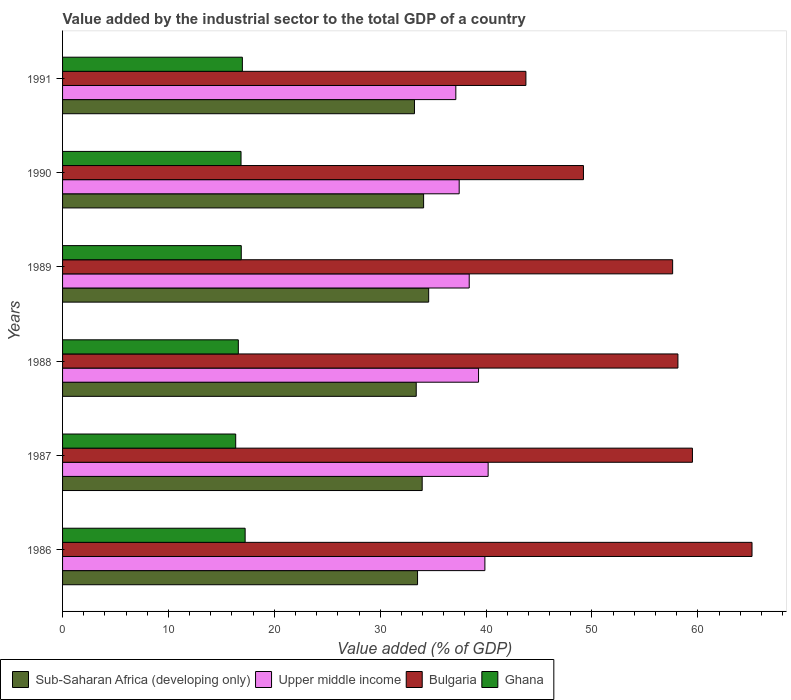Are the number of bars per tick equal to the number of legend labels?
Ensure brevity in your answer.  Yes. Are the number of bars on each tick of the Y-axis equal?
Provide a succinct answer. Yes. How many bars are there on the 3rd tick from the top?
Offer a terse response. 4. How many bars are there on the 5th tick from the bottom?
Offer a very short reply. 4. In how many cases, is the number of bars for a given year not equal to the number of legend labels?
Your response must be concise. 0. What is the value added by the industrial sector to the total GDP in Ghana in 1988?
Give a very brief answer. 16.6. Across all years, what is the maximum value added by the industrial sector to the total GDP in Sub-Saharan Africa (developing only)?
Give a very brief answer. 34.58. Across all years, what is the minimum value added by the industrial sector to the total GDP in Bulgaria?
Offer a terse response. 43.76. In which year was the value added by the industrial sector to the total GDP in Sub-Saharan Africa (developing only) minimum?
Keep it short and to the point. 1991. What is the total value added by the industrial sector to the total GDP in Sub-Saharan Africa (developing only) in the graph?
Offer a terse response. 202.81. What is the difference between the value added by the industrial sector to the total GDP in Ghana in 1986 and that in 1990?
Ensure brevity in your answer.  0.39. What is the difference between the value added by the industrial sector to the total GDP in Upper middle income in 1987 and the value added by the industrial sector to the total GDP in Ghana in 1991?
Your answer should be very brief. 23.21. What is the average value added by the industrial sector to the total GDP in Ghana per year?
Make the answer very short. 16.82. In the year 1990, what is the difference between the value added by the industrial sector to the total GDP in Sub-Saharan Africa (developing only) and value added by the industrial sector to the total GDP in Upper middle income?
Keep it short and to the point. -3.36. What is the ratio of the value added by the industrial sector to the total GDP in Upper middle income in 1990 to that in 1991?
Give a very brief answer. 1.01. What is the difference between the highest and the second highest value added by the industrial sector to the total GDP in Ghana?
Your answer should be very brief. 0.26. What is the difference between the highest and the lowest value added by the industrial sector to the total GDP in Bulgaria?
Provide a short and direct response. 21.36. In how many years, is the value added by the industrial sector to the total GDP in Sub-Saharan Africa (developing only) greater than the average value added by the industrial sector to the total GDP in Sub-Saharan Africa (developing only) taken over all years?
Provide a succinct answer. 3. Is the sum of the value added by the industrial sector to the total GDP in Upper middle income in 1990 and 1991 greater than the maximum value added by the industrial sector to the total GDP in Bulgaria across all years?
Ensure brevity in your answer.  Yes. Is it the case that in every year, the sum of the value added by the industrial sector to the total GDP in Ghana and value added by the industrial sector to the total GDP in Bulgaria is greater than the sum of value added by the industrial sector to the total GDP in Upper middle income and value added by the industrial sector to the total GDP in Sub-Saharan Africa (developing only)?
Offer a very short reply. No. What does the 2nd bar from the top in 1989 represents?
Your answer should be very brief. Bulgaria. What does the 1st bar from the bottom in 1986 represents?
Your response must be concise. Sub-Saharan Africa (developing only). Is it the case that in every year, the sum of the value added by the industrial sector to the total GDP in Sub-Saharan Africa (developing only) and value added by the industrial sector to the total GDP in Upper middle income is greater than the value added by the industrial sector to the total GDP in Bulgaria?
Ensure brevity in your answer.  Yes. What is the difference between two consecutive major ticks on the X-axis?
Keep it short and to the point. 10. Does the graph contain grids?
Ensure brevity in your answer.  No. Where does the legend appear in the graph?
Provide a succinct answer. Bottom left. How are the legend labels stacked?
Your answer should be very brief. Horizontal. What is the title of the graph?
Provide a succinct answer. Value added by the industrial sector to the total GDP of a country. What is the label or title of the X-axis?
Provide a succinct answer. Value added (% of GDP). What is the Value added (% of GDP) of Sub-Saharan Africa (developing only) in 1986?
Provide a short and direct response. 33.53. What is the Value added (% of GDP) in Upper middle income in 1986?
Give a very brief answer. 39.89. What is the Value added (% of GDP) in Bulgaria in 1986?
Keep it short and to the point. 65.12. What is the Value added (% of GDP) in Ghana in 1986?
Provide a short and direct response. 17.24. What is the Value added (% of GDP) in Sub-Saharan Africa (developing only) in 1987?
Make the answer very short. 33.97. What is the Value added (% of GDP) in Upper middle income in 1987?
Make the answer very short. 40.19. What is the Value added (% of GDP) in Bulgaria in 1987?
Your response must be concise. 59.49. What is the Value added (% of GDP) of Ghana in 1987?
Offer a very short reply. 16.35. What is the Value added (% of GDP) of Sub-Saharan Africa (developing only) in 1988?
Keep it short and to the point. 33.4. What is the Value added (% of GDP) in Upper middle income in 1988?
Provide a succinct answer. 39.29. What is the Value added (% of GDP) in Bulgaria in 1988?
Provide a succinct answer. 58.12. What is the Value added (% of GDP) in Ghana in 1988?
Ensure brevity in your answer.  16.6. What is the Value added (% of GDP) in Sub-Saharan Africa (developing only) in 1989?
Provide a succinct answer. 34.58. What is the Value added (% of GDP) in Upper middle income in 1989?
Keep it short and to the point. 38.41. What is the Value added (% of GDP) in Bulgaria in 1989?
Provide a short and direct response. 57.62. What is the Value added (% of GDP) in Ghana in 1989?
Your response must be concise. 16.88. What is the Value added (% of GDP) of Sub-Saharan Africa (developing only) in 1990?
Offer a terse response. 34.1. What is the Value added (% of GDP) in Upper middle income in 1990?
Make the answer very short. 37.46. What is the Value added (% of GDP) of Bulgaria in 1990?
Your answer should be very brief. 49.2. What is the Value added (% of GDP) of Ghana in 1990?
Give a very brief answer. 16.86. What is the Value added (% of GDP) of Sub-Saharan Africa (developing only) in 1991?
Your answer should be compact. 33.24. What is the Value added (% of GDP) in Upper middle income in 1991?
Give a very brief answer. 37.14. What is the Value added (% of GDP) in Bulgaria in 1991?
Ensure brevity in your answer.  43.76. What is the Value added (% of GDP) of Ghana in 1991?
Offer a terse response. 16.98. Across all years, what is the maximum Value added (% of GDP) of Sub-Saharan Africa (developing only)?
Your answer should be compact. 34.58. Across all years, what is the maximum Value added (% of GDP) of Upper middle income?
Give a very brief answer. 40.19. Across all years, what is the maximum Value added (% of GDP) in Bulgaria?
Your answer should be very brief. 65.12. Across all years, what is the maximum Value added (% of GDP) of Ghana?
Keep it short and to the point. 17.24. Across all years, what is the minimum Value added (% of GDP) in Sub-Saharan Africa (developing only)?
Keep it short and to the point. 33.24. Across all years, what is the minimum Value added (% of GDP) in Upper middle income?
Make the answer very short. 37.14. Across all years, what is the minimum Value added (% of GDP) of Bulgaria?
Your response must be concise. 43.76. Across all years, what is the minimum Value added (% of GDP) in Ghana?
Your answer should be very brief. 16.35. What is the total Value added (% of GDP) of Sub-Saharan Africa (developing only) in the graph?
Your response must be concise. 202.81. What is the total Value added (% of GDP) in Upper middle income in the graph?
Provide a succinct answer. 232.38. What is the total Value added (% of GDP) in Bulgaria in the graph?
Ensure brevity in your answer.  333.3. What is the total Value added (% of GDP) of Ghana in the graph?
Provide a succinct answer. 100.91. What is the difference between the Value added (% of GDP) of Sub-Saharan Africa (developing only) in 1986 and that in 1987?
Ensure brevity in your answer.  -0.44. What is the difference between the Value added (% of GDP) of Upper middle income in 1986 and that in 1987?
Keep it short and to the point. -0.31. What is the difference between the Value added (% of GDP) of Bulgaria in 1986 and that in 1987?
Your answer should be compact. 5.63. What is the difference between the Value added (% of GDP) in Ghana in 1986 and that in 1987?
Your answer should be compact. 0.89. What is the difference between the Value added (% of GDP) in Sub-Saharan Africa (developing only) in 1986 and that in 1988?
Keep it short and to the point. 0.12. What is the difference between the Value added (% of GDP) of Upper middle income in 1986 and that in 1988?
Offer a very short reply. 0.6. What is the difference between the Value added (% of GDP) in Bulgaria in 1986 and that in 1988?
Your answer should be very brief. 7. What is the difference between the Value added (% of GDP) of Ghana in 1986 and that in 1988?
Offer a terse response. 0.64. What is the difference between the Value added (% of GDP) of Sub-Saharan Africa (developing only) in 1986 and that in 1989?
Make the answer very short. -1.05. What is the difference between the Value added (% of GDP) in Upper middle income in 1986 and that in 1989?
Make the answer very short. 1.48. What is the difference between the Value added (% of GDP) in Bulgaria in 1986 and that in 1989?
Your response must be concise. 7.5. What is the difference between the Value added (% of GDP) in Ghana in 1986 and that in 1989?
Provide a succinct answer. 0.37. What is the difference between the Value added (% of GDP) in Sub-Saharan Africa (developing only) in 1986 and that in 1990?
Offer a very short reply. -0.57. What is the difference between the Value added (% of GDP) of Upper middle income in 1986 and that in 1990?
Keep it short and to the point. 2.43. What is the difference between the Value added (% of GDP) of Bulgaria in 1986 and that in 1990?
Provide a short and direct response. 15.92. What is the difference between the Value added (% of GDP) of Ghana in 1986 and that in 1990?
Offer a terse response. 0.39. What is the difference between the Value added (% of GDP) in Sub-Saharan Africa (developing only) in 1986 and that in 1991?
Ensure brevity in your answer.  0.29. What is the difference between the Value added (% of GDP) of Upper middle income in 1986 and that in 1991?
Keep it short and to the point. 2.75. What is the difference between the Value added (% of GDP) of Bulgaria in 1986 and that in 1991?
Provide a succinct answer. 21.36. What is the difference between the Value added (% of GDP) in Ghana in 1986 and that in 1991?
Give a very brief answer. 0.26. What is the difference between the Value added (% of GDP) in Sub-Saharan Africa (developing only) in 1987 and that in 1988?
Provide a short and direct response. 0.56. What is the difference between the Value added (% of GDP) of Upper middle income in 1987 and that in 1988?
Offer a terse response. 0.9. What is the difference between the Value added (% of GDP) of Bulgaria in 1987 and that in 1988?
Keep it short and to the point. 1.37. What is the difference between the Value added (% of GDP) of Ghana in 1987 and that in 1988?
Your response must be concise. -0.25. What is the difference between the Value added (% of GDP) of Sub-Saharan Africa (developing only) in 1987 and that in 1989?
Your answer should be compact. -0.61. What is the difference between the Value added (% of GDP) in Upper middle income in 1987 and that in 1989?
Your answer should be compact. 1.79. What is the difference between the Value added (% of GDP) in Bulgaria in 1987 and that in 1989?
Offer a terse response. 1.87. What is the difference between the Value added (% of GDP) of Ghana in 1987 and that in 1989?
Provide a short and direct response. -0.53. What is the difference between the Value added (% of GDP) of Sub-Saharan Africa (developing only) in 1987 and that in 1990?
Your response must be concise. -0.13. What is the difference between the Value added (% of GDP) of Upper middle income in 1987 and that in 1990?
Keep it short and to the point. 2.73. What is the difference between the Value added (% of GDP) in Bulgaria in 1987 and that in 1990?
Your answer should be compact. 10.29. What is the difference between the Value added (% of GDP) in Ghana in 1987 and that in 1990?
Provide a succinct answer. -0.5. What is the difference between the Value added (% of GDP) in Sub-Saharan Africa (developing only) in 1987 and that in 1991?
Your answer should be compact. 0.73. What is the difference between the Value added (% of GDP) in Upper middle income in 1987 and that in 1991?
Offer a terse response. 3.05. What is the difference between the Value added (% of GDP) of Bulgaria in 1987 and that in 1991?
Make the answer very short. 15.73. What is the difference between the Value added (% of GDP) in Ghana in 1987 and that in 1991?
Provide a succinct answer. -0.63. What is the difference between the Value added (% of GDP) of Sub-Saharan Africa (developing only) in 1988 and that in 1989?
Make the answer very short. -1.17. What is the difference between the Value added (% of GDP) in Upper middle income in 1988 and that in 1989?
Give a very brief answer. 0.88. What is the difference between the Value added (% of GDP) of Bulgaria in 1988 and that in 1989?
Offer a terse response. 0.5. What is the difference between the Value added (% of GDP) in Ghana in 1988 and that in 1989?
Your response must be concise. -0.28. What is the difference between the Value added (% of GDP) in Sub-Saharan Africa (developing only) in 1988 and that in 1990?
Your answer should be very brief. -0.7. What is the difference between the Value added (% of GDP) in Upper middle income in 1988 and that in 1990?
Your response must be concise. 1.83. What is the difference between the Value added (% of GDP) in Bulgaria in 1988 and that in 1990?
Give a very brief answer. 8.92. What is the difference between the Value added (% of GDP) of Ghana in 1988 and that in 1990?
Make the answer very short. -0.25. What is the difference between the Value added (% of GDP) of Sub-Saharan Africa (developing only) in 1988 and that in 1991?
Your response must be concise. 0.17. What is the difference between the Value added (% of GDP) of Upper middle income in 1988 and that in 1991?
Provide a short and direct response. 2.15. What is the difference between the Value added (% of GDP) of Bulgaria in 1988 and that in 1991?
Your response must be concise. 14.36. What is the difference between the Value added (% of GDP) of Ghana in 1988 and that in 1991?
Your response must be concise. -0.38. What is the difference between the Value added (% of GDP) of Sub-Saharan Africa (developing only) in 1989 and that in 1990?
Your answer should be very brief. 0.48. What is the difference between the Value added (% of GDP) of Upper middle income in 1989 and that in 1990?
Ensure brevity in your answer.  0.95. What is the difference between the Value added (% of GDP) of Bulgaria in 1989 and that in 1990?
Ensure brevity in your answer.  8.42. What is the difference between the Value added (% of GDP) in Ghana in 1989 and that in 1990?
Your answer should be very brief. 0.02. What is the difference between the Value added (% of GDP) of Sub-Saharan Africa (developing only) in 1989 and that in 1991?
Give a very brief answer. 1.34. What is the difference between the Value added (% of GDP) in Upper middle income in 1989 and that in 1991?
Keep it short and to the point. 1.26. What is the difference between the Value added (% of GDP) of Bulgaria in 1989 and that in 1991?
Offer a terse response. 13.86. What is the difference between the Value added (% of GDP) of Ghana in 1989 and that in 1991?
Your answer should be compact. -0.1. What is the difference between the Value added (% of GDP) of Sub-Saharan Africa (developing only) in 1990 and that in 1991?
Offer a terse response. 0.86. What is the difference between the Value added (% of GDP) in Upper middle income in 1990 and that in 1991?
Provide a succinct answer. 0.32. What is the difference between the Value added (% of GDP) in Bulgaria in 1990 and that in 1991?
Give a very brief answer. 5.44. What is the difference between the Value added (% of GDP) of Ghana in 1990 and that in 1991?
Give a very brief answer. -0.13. What is the difference between the Value added (% of GDP) of Sub-Saharan Africa (developing only) in 1986 and the Value added (% of GDP) of Upper middle income in 1987?
Make the answer very short. -6.67. What is the difference between the Value added (% of GDP) in Sub-Saharan Africa (developing only) in 1986 and the Value added (% of GDP) in Bulgaria in 1987?
Ensure brevity in your answer.  -25.96. What is the difference between the Value added (% of GDP) of Sub-Saharan Africa (developing only) in 1986 and the Value added (% of GDP) of Ghana in 1987?
Keep it short and to the point. 17.17. What is the difference between the Value added (% of GDP) in Upper middle income in 1986 and the Value added (% of GDP) in Bulgaria in 1987?
Your response must be concise. -19.6. What is the difference between the Value added (% of GDP) of Upper middle income in 1986 and the Value added (% of GDP) of Ghana in 1987?
Make the answer very short. 23.54. What is the difference between the Value added (% of GDP) of Bulgaria in 1986 and the Value added (% of GDP) of Ghana in 1987?
Offer a very short reply. 48.76. What is the difference between the Value added (% of GDP) of Sub-Saharan Africa (developing only) in 1986 and the Value added (% of GDP) of Upper middle income in 1988?
Keep it short and to the point. -5.76. What is the difference between the Value added (% of GDP) of Sub-Saharan Africa (developing only) in 1986 and the Value added (% of GDP) of Bulgaria in 1988?
Your answer should be very brief. -24.59. What is the difference between the Value added (% of GDP) in Sub-Saharan Africa (developing only) in 1986 and the Value added (% of GDP) in Ghana in 1988?
Your response must be concise. 16.93. What is the difference between the Value added (% of GDP) in Upper middle income in 1986 and the Value added (% of GDP) in Bulgaria in 1988?
Offer a very short reply. -18.23. What is the difference between the Value added (% of GDP) of Upper middle income in 1986 and the Value added (% of GDP) of Ghana in 1988?
Provide a short and direct response. 23.29. What is the difference between the Value added (% of GDP) of Bulgaria in 1986 and the Value added (% of GDP) of Ghana in 1988?
Your answer should be very brief. 48.52. What is the difference between the Value added (% of GDP) in Sub-Saharan Africa (developing only) in 1986 and the Value added (% of GDP) in Upper middle income in 1989?
Give a very brief answer. -4.88. What is the difference between the Value added (% of GDP) in Sub-Saharan Africa (developing only) in 1986 and the Value added (% of GDP) in Bulgaria in 1989?
Provide a succinct answer. -24.09. What is the difference between the Value added (% of GDP) in Sub-Saharan Africa (developing only) in 1986 and the Value added (% of GDP) in Ghana in 1989?
Your answer should be very brief. 16.65. What is the difference between the Value added (% of GDP) in Upper middle income in 1986 and the Value added (% of GDP) in Bulgaria in 1989?
Offer a terse response. -17.73. What is the difference between the Value added (% of GDP) of Upper middle income in 1986 and the Value added (% of GDP) of Ghana in 1989?
Offer a very short reply. 23.01. What is the difference between the Value added (% of GDP) in Bulgaria in 1986 and the Value added (% of GDP) in Ghana in 1989?
Provide a succinct answer. 48.24. What is the difference between the Value added (% of GDP) of Sub-Saharan Africa (developing only) in 1986 and the Value added (% of GDP) of Upper middle income in 1990?
Your response must be concise. -3.93. What is the difference between the Value added (% of GDP) in Sub-Saharan Africa (developing only) in 1986 and the Value added (% of GDP) in Bulgaria in 1990?
Ensure brevity in your answer.  -15.67. What is the difference between the Value added (% of GDP) in Sub-Saharan Africa (developing only) in 1986 and the Value added (% of GDP) in Ghana in 1990?
Your answer should be compact. 16.67. What is the difference between the Value added (% of GDP) in Upper middle income in 1986 and the Value added (% of GDP) in Bulgaria in 1990?
Keep it short and to the point. -9.31. What is the difference between the Value added (% of GDP) in Upper middle income in 1986 and the Value added (% of GDP) in Ghana in 1990?
Offer a terse response. 23.03. What is the difference between the Value added (% of GDP) of Bulgaria in 1986 and the Value added (% of GDP) of Ghana in 1990?
Your response must be concise. 48.26. What is the difference between the Value added (% of GDP) in Sub-Saharan Africa (developing only) in 1986 and the Value added (% of GDP) in Upper middle income in 1991?
Your answer should be very brief. -3.62. What is the difference between the Value added (% of GDP) of Sub-Saharan Africa (developing only) in 1986 and the Value added (% of GDP) of Bulgaria in 1991?
Your answer should be very brief. -10.23. What is the difference between the Value added (% of GDP) in Sub-Saharan Africa (developing only) in 1986 and the Value added (% of GDP) in Ghana in 1991?
Make the answer very short. 16.54. What is the difference between the Value added (% of GDP) in Upper middle income in 1986 and the Value added (% of GDP) in Bulgaria in 1991?
Provide a short and direct response. -3.87. What is the difference between the Value added (% of GDP) of Upper middle income in 1986 and the Value added (% of GDP) of Ghana in 1991?
Give a very brief answer. 22.9. What is the difference between the Value added (% of GDP) in Bulgaria in 1986 and the Value added (% of GDP) in Ghana in 1991?
Keep it short and to the point. 48.13. What is the difference between the Value added (% of GDP) of Sub-Saharan Africa (developing only) in 1987 and the Value added (% of GDP) of Upper middle income in 1988?
Your response must be concise. -5.32. What is the difference between the Value added (% of GDP) of Sub-Saharan Africa (developing only) in 1987 and the Value added (% of GDP) of Bulgaria in 1988?
Your answer should be compact. -24.15. What is the difference between the Value added (% of GDP) of Sub-Saharan Africa (developing only) in 1987 and the Value added (% of GDP) of Ghana in 1988?
Ensure brevity in your answer.  17.37. What is the difference between the Value added (% of GDP) in Upper middle income in 1987 and the Value added (% of GDP) in Bulgaria in 1988?
Provide a short and direct response. -17.92. What is the difference between the Value added (% of GDP) of Upper middle income in 1987 and the Value added (% of GDP) of Ghana in 1988?
Make the answer very short. 23.59. What is the difference between the Value added (% of GDP) in Bulgaria in 1987 and the Value added (% of GDP) in Ghana in 1988?
Provide a succinct answer. 42.89. What is the difference between the Value added (% of GDP) of Sub-Saharan Africa (developing only) in 1987 and the Value added (% of GDP) of Upper middle income in 1989?
Your answer should be compact. -4.44. What is the difference between the Value added (% of GDP) of Sub-Saharan Africa (developing only) in 1987 and the Value added (% of GDP) of Bulgaria in 1989?
Make the answer very short. -23.65. What is the difference between the Value added (% of GDP) in Sub-Saharan Africa (developing only) in 1987 and the Value added (% of GDP) in Ghana in 1989?
Your answer should be very brief. 17.09. What is the difference between the Value added (% of GDP) of Upper middle income in 1987 and the Value added (% of GDP) of Bulgaria in 1989?
Make the answer very short. -17.43. What is the difference between the Value added (% of GDP) in Upper middle income in 1987 and the Value added (% of GDP) in Ghana in 1989?
Provide a succinct answer. 23.32. What is the difference between the Value added (% of GDP) of Bulgaria in 1987 and the Value added (% of GDP) of Ghana in 1989?
Provide a short and direct response. 42.61. What is the difference between the Value added (% of GDP) of Sub-Saharan Africa (developing only) in 1987 and the Value added (% of GDP) of Upper middle income in 1990?
Keep it short and to the point. -3.49. What is the difference between the Value added (% of GDP) of Sub-Saharan Africa (developing only) in 1987 and the Value added (% of GDP) of Bulgaria in 1990?
Keep it short and to the point. -15.23. What is the difference between the Value added (% of GDP) of Sub-Saharan Africa (developing only) in 1987 and the Value added (% of GDP) of Ghana in 1990?
Keep it short and to the point. 17.11. What is the difference between the Value added (% of GDP) of Upper middle income in 1987 and the Value added (% of GDP) of Bulgaria in 1990?
Provide a short and direct response. -9. What is the difference between the Value added (% of GDP) in Upper middle income in 1987 and the Value added (% of GDP) in Ghana in 1990?
Provide a succinct answer. 23.34. What is the difference between the Value added (% of GDP) in Bulgaria in 1987 and the Value added (% of GDP) in Ghana in 1990?
Make the answer very short. 42.64. What is the difference between the Value added (% of GDP) in Sub-Saharan Africa (developing only) in 1987 and the Value added (% of GDP) in Upper middle income in 1991?
Your response must be concise. -3.18. What is the difference between the Value added (% of GDP) in Sub-Saharan Africa (developing only) in 1987 and the Value added (% of GDP) in Bulgaria in 1991?
Your response must be concise. -9.8. What is the difference between the Value added (% of GDP) in Sub-Saharan Africa (developing only) in 1987 and the Value added (% of GDP) in Ghana in 1991?
Provide a succinct answer. 16.98. What is the difference between the Value added (% of GDP) of Upper middle income in 1987 and the Value added (% of GDP) of Bulgaria in 1991?
Offer a terse response. -3.57. What is the difference between the Value added (% of GDP) of Upper middle income in 1987 and the Value added (% of GDP) of Ghana in 1991?
Offer a terse response. 23.21. What is the difference between the Value added (% of GDP) of Bulgaria in 1987 and the Value added (% of GDP) of Ghana in 1991?
Give a very brief answer. 42.51. What is the difference between the Value added (% of GDP) of Sub-Saharan Africa (developing only) in 1988 and the Value added (% of GDP) of Upper middle income in 1989?
Give a very brief answer. -5. What is the difference between the Value added (% of GDP) in Sub-Saharan Africa (developing only) in 1988 and the Value added (% of GDP) in Bulgaria in 1989?
Provide a short and direct response. -24.22. What is the difference between the Value added (% of GDP) of Sub-Saharan Africa (developing only) in 1988 and the Value added (% of GDP) of Ghana in 1989?
Provide a short and direct response. 16.53. What is the difference between the Value added (% of GDP) in Upper middle income in 1988 and the Value added (% of GDP) in Bulgaria in 1989?
Ensure brevity in your answer.  -18.33. What is the difference between the Value added (% of GDP) in Upper middle income in 1988 and the Value added (% of GDP) in Ghana in 1989?
Keep it short and to the point. 22.41. What is the difference between the Value added (% of GDP) of Bulgaria in 1988 and the Value added (% of GDP) of Ghana in 1989?
Your answer should be very brief. 41.24. What is the difference between the Value added (% of GDP) of Sub-Saharan Africa (developing only) in 1988 and the Value added (% of GDP) of Upper middle income in 1990?
Provide a succinct answer. -4.06. What is the difference between the Value added (% of GDP) in Sub-Saharan Africa (developing only) in 1988 and the Value added (% of GDP) in Bulgaria in 1990?
Your answer should be compact. -15.79. What is the difference between the Value added (% of GDP) in Sub-Saharan Africa (developing only) in 1988 and the Value added (% of GDP) in Ghana in 1990?
Give a very brief answer. 16.55. What is the difference between the Value added (% of GDP) of Upper middle income in 1988 and the Value added (% of GDP) of Bulgaria in 1990?
Make the answer very short. -9.91. What is the difference between the Value added (% of GDP) of Upper middle income in 1988 and the Value added (% of GDP) of Ghana in 1990?
Ensure brevity in your answer.  22.43. What is the difference between the Value added (% of GDP) of Bulgaria in 1988 and the Value added (% of GDP) of Ghana in 1990?
Offer a terse response. 41.26. What is the difference between the Value added (% of GDP) in Sub-Saharan Africa (developing only) in 1988 and the Value added (% of GDP) in Upper middle income in 1991?
Your answer should be compact. -3.74. What is the difference between the Value added (% of GDP) of Sub-Saharan Africa (developing only) in 1988 and the Value added (% of GDP) of Bulgaria in 1991?
Your answer should be compact. -10.36. What is the difference between the Value added (% of GDP) of Sub-Saharan Africa (developing only) in 1988 and the Value added (% of GDP) of Ghana in 1991?
Provide a succinct answer. 16.42. What is the difference between the Value added (% of GDP) of Upper middle income in 1988 and the Value added (% of GDP) of Bulgaria in 1991?
Your answer should be compact. -4.47. What is the difference between the Value added (% of GDP) of Upper middle income in 1988 and the Value added (% of GDP) of Ghana in 1991?
Ensure brevity in your answer.  22.31. What is the difference between the Value added (% of GDP) in Bulgaria in 1988 and the Value added (% of GDP) in Ghana in 1991?
Make the answer very short. 41.14. What is the difference between the Value added (% of GDP) of Sub-Saharan Africa (developing only) in 1989 and the Value added (% of GDP) of Upper middle income in 1990?
Give a very brief answer. -2.88. What is the difference between the Value added (% of GDP) of Sub-Saharan Africa (developing only) in 1989 and the Value added (% of GDP) of Bulgaria in 1990?
Provide a succinct answer. -14.62. What is the difference between the Value added (% of GDP) in Sub-Saharan Africa (developing only) in 1989 and the Value added (% of GDP) in Ghana in 1990?
Your answer should be compact. 17.72. What is the difference between the Value added (% of GDP) of Upper middle income in 1989 and the Value added (% of GDP) of Bulgaria in 1990?
Your answer should be compact. -10.79. What is the difference between the Value added (% of GDP) in Upper middle income in 1989 and the Value added (% of GDP) in Ghana in 1990?
Offer a terse response. 21.55. What is the difference between the Value added (% of GDP) of Bulgaria in 1989 and the Value added (% of GDP) of Ghana in 1990?
Your answer should be compact. 40.76. What is the difference between the Value added (% of GDP) of Sub-Saharan Africa (developing only) in 1989 and the Value added (% of GDP) of Upper middle income in 1991?
Offer a terse response. -2.56. What is the difference between the Value added (% of GDP) of Sub-Saharan Africa (developing only) in 1989 and the Value added (% of GDP) of Bulgaria in 1991?
Your answer should be very brief. -9.18. What is the difference between the Value added (% of GDP) in Sub-Saharan Africa (developing only) in 1989 and the Value added (% of GDP) in Ghana in 1991?
Your response must be concise. 17.59. What is the difference between the Value added (% of GDP) in Upper middle income in 1989 and the Value added (% of GDP) in Bulgaria in 1991?
Give a very brief answer. -5.35. What is the difference between the Value added (% of GDP) of Upper middle income in 1989 and the Value added (% of GDP) of Ghana in 1991?
Offer a very short reply. 21.42. What is the difference between the Value added (% of GDP) of Bulgaria in 1989 and the Value added (% of GDP) of Ghana in 1991?
Provide a short and direct response. 40.64. What is the difference between the Value added (% of GDP) of Sub-Saharan Africa (developing only) in 1990 and the Value added (% of GDP) of Upper middle income in 1991?
Make the answer very short. -3.04. What is the difference between the Value added (% of GDP) in Sub-Saharan Africa (developing only) in 1990 and the Value added (% of GDP) in Bulgaria in 1991?
Keep it short and to the point. -9.66. What is the difference between the Value added (% of GDP) of Sub-Saharan Africa (developing only) in 1990 and the Value added (% of GDP) of Ghana in 1991?
Offer a very short reply. 17.12. What is the difference between the Value added (% of GDP) in Upper middle income in 1990 and the Value added (% of GDP) in Bulgaria in 1991?
Make the answer very short. -6.3. What is the difference between the Value added (% of GDP) in Upper middle income in 1990 and the Value added (% of GDP) in Ghana in 1991?
Provide a short and direct response. 20.48. What is the difference between the Value added (% of GDP) of Bulgaria in 1990 and the Value added (% of GDP) of Ghana in 1991?
Make the answer very short. 32.21. What is the average Value added (% of GDP) in Sub-Saharan Africa (developing only) per year?
Provide a succinct answer. 33.8. What is the average Value added (% of GDP) in Upper middle income per year?
Give a very brief answer. 38.73. What is the average Value added (% of GDP) of Bulgaria per year?
Make the answer very short. 55.55. What is the average Value added (% of GDP) in Ghana per year?
Your response must be concise. 16.82. In the year 1986, what is the difference between the Value added (% of GDP) in Sub-Saharan Africa (developing only) and Value added (% of GDP) in Upper middle income?
Your answer should be compact. -6.36. In the year 1986, what is the difference between the Value added (% of GDP) in Sub-Saharan Africa (developing only) and Value added (% of GDP) in Bulgaria?
Your answer should be very brief. -31.59. In the year 1986, what is the difference between the Value added (% of GDP) of Sub-Saharan Africa (developing only) and Value added (% of GDP) of Ghana?
Your response must be concise. 16.28. In the year 1986, what is the difference between the Value added (% of GDP) of Upper middle income and Value added (% of GDP) of Bulgaria?
Ensure brevity in your answer.  -25.23. In the year 1986, what is the difference between the Value added (% of GDP) in Upper middle income and Value added (% of GDP) in Ghana?
Ensure brevity in your answer.  22.64. In the year 1986, what is the difference between the Value added (% of GDP) in Bulgaria and Value added (% of GDP) in Ghana?
Ensure brevity in your answer.  47.87. In the year 1987, what is the difference between the Value added (% of GDP) of Sub-Saharan Africa (developing only) and Value added (% of GDP) of Upper middle income?
Your answer should be compact. -6.23. In the year 1987, what is the difference between the Value added (% of GDP) in Sub-Saharan Africa (developing only) and Value added (% of GDP) in Bulgaria?
Provide a short and direct response. -25.52. In the year 1987, what is the difference between the Value added (% of GDP) of Sub-Saharan Africa (developing only) and Value added (% of GDP) of Ghana?
Offer a very short reply. 17.61. In the year 1987, what is the difference between the Value added (% of GDP) in Upper middle income and Value added (% of GDP) in Bulgaria?
Keep it short and to the point. -19.3. In the year 1987, what is the difference between the Value added (% of GDP) in Upper middle income and Value added (% of GDP) in Ghana?
Your answer should be very brief. 23.84. In the year 1987, what is the difference between the Value added (% of GDP) of Bulgaria and Value added (% of GDP) of Ghana?
Offer a very short reply. 43.14. In the year 1988, what is the difference between the Value added (% of GDP) of Sub-Saharan Africa (developing only) and Value added (% of GDP) of Upper middle income?
Offer a terse response. -5.89. In the year 1988, what is the difference between the Value added (% of GDP) of Sub-Saharan Africa (developing only) and Value added (% of GDP) of Bulgaria?
Ensure brevity in your answer.  -24.71. In the year 1988, what is the difference between the Value added (% of GDP) in Sub-Saharan Africa (developing only) and Value added (% of GDP) in Ghana?
Make the answer very short. 16.8. In the year 1988, what is the difference between the Value added (% of GDP) of Upper middle income and Value added (% of GDP) of Bulgaria?
Your response must be concise. -18.83. In the year 1988, what is the difference between the Value added (% of GDP) of Upper middle income and Value added (% of GDP) of Ghana?
Provide a succinct answer. 22.69. In the year 1988, what is the difference between the Value added (% of GDP) of Bulgaria and Value added (% of GDP) of Ghana?
Offer a terse response. 41.52. In the year 1989, what is the difference between the Value added (% of GDP) in Sub-Saharan Africa (developing only) and Value added (% of GDP) in Upper middle income?
Your answer should be compact. -3.83. In the year 1989, what is the difference between the Value added (% of GDP) of Sub-Saharan Africa (developing only) and Value added (% of GDP) of Bulgaria?
Provide a succinct answer. -23.04. In the year 1989, what is the difference between the Value added (% of GDP) of Sub-Saharan Africa (developing only) and Value added (% of GDP) of Ghana?
Make the answer very short. 17.7. In the year 1989, what is the difference between the Value added (% of GDP) of Upper middle income and Value added (% of GDP) of Bulgaria?
Your answer should be compact. -19.21. In the year 1989, what is the difference between the Value added (% of GDP) of Upper middle income and Value added (% of GDP) of Ghana?
Your response must be concise. 21.53. In the year 1989, what is the difference between the Value added (% of GDP) of Bulgaria and Value added (% of GDP) of Ghana?
Keep it short and to the point. 40.74. In the year 1990, what is the difference between the Value added (% of GDP) of Sub-Saharan Africa (developing only) and Value added (% of GDP) of Upper middle income?
Your response must be concise. -3.36. In the year 1990, what is the difference between the Value added (% of GDP) of Sub-Saharan Africa (developing only) and Value added (% of GDP) of Bulgaria?
Make the answer very short. -15.1. In the year 1990, what is the difference between the Value added (% of GDP) of Sub-Saharan Africa (developing only) and Value added (% of GDP) of Ghana?
Offer a very short reply. 17.25. In the year 1990, what is the difference between the Value added (% of GDP) in Upper middle income and Value added (% of GDP) in Bulgaria?
Offer a terse response. -11.74. In the year 1990, what is the difference between the Value added (% of GDP) of Upper middle income and Value added (% of GDP) of Ghana?
Provide a short and direct response. 20.6. In the year 1990, what is the difference between the Value added (% of GDP) in Bulgaria and Value added (% of GDP) in Ghana?
Provide a short and direct response. 32.34. In the year 1991, what is the difference between the Value added (% of GDP) in Sub-Saharan Africa (developing only) and Value added (% of GDP) in Upper middle income?
Your answer should be compact. -3.91. In the year 1991, what is the difference between the Value added (% of GDP) of Sub-Saharan Africa (developing only) and Value added (% of GDP) of Bulgaria?
Give a very brief answer. -10.53. In the year 1991, what is the difference between the Value added (% of GDP) in Sub-Saharan Africa (developing only) and Value added (% of GDP) in Ghana?
Provide a succinct answer. 16.25. In the year 1991, what is the difference between the Value added (% of GDP) of Upper middle income and Value added (% of GDP) of Bulgaria?
Provide a succinct answer. -6.62. In the year 1991, what is the difference between the Value added (% of GDP) in Upper middle income and Value added (% of GDP) in Ghana?
Offer a very short reply. 20.16. In the year 1991, what is the difference between the Value added (% of GDP) of Bulgaria and Value added (% of GDP) of Ghana?
Make the answer very short. 26.78. What is the ratio of the Value added (% of GDP) of Sub-Saharan Africa (developing only) in 1986 to that in 1987?
Your answer should be very brief. 0.99. What is the ratio of the Value added (% of GDP) of Upper middle income in 1986 to that in 1987?
Your response must be concise. 0.99. What is the ratio of the Value added (% of GDP) in Bulgaria in 1986 to that in 1987?
Give a very brief answer. 1.09. What is the ratio of the Value added (% of GDP) of Ghana in 1986 to that in 1987?
Provide a succinct answer. 1.05. What is the ratio of the Value added (% of GDP) of Upper middle income in 1986 to that in 1988?
Ensure brevity in your answer.  1.02. What is the ratio of the Value added (% of GDP) of Bulgaria in 1986 to that in 1988?
Ensure brevity in your answer.  1.12. What is the ratio of the Value added (% of GDP) in Ghana in 1986 to that in 1988?
Ensure brevity in your answer.  1.04. What is the ratio of the Value added (% of GDP) in Sub-Saharan Africa (developing only) in 1986 to that in 1989?
Your answer should be compact. 0.97. What is the ratio of the Value added (% of GDP) of Upper middle income in 1986 to that in 1989?
Offer a very short reply. 1.04. What is the ratio of the Value added (% of GDP) in Bulgaria in 1986 to that in 1989?
Offer a very short reply. 1.13. What is the ratio of the Value added (% of GDP) of Ghana in 1986 to that in 1989?
Your answer should be compact. 1.02. What is the ratio of the Value added (% of GDP) in Sub-Saharan Africa (developing only) in 1986 to that in 1990?
Your answer should be compact. 0.98. What is the ratio of the Value added (% of GDP) of Upper middle income in 1986 to that in 1990?
Ensure brevity in your answer.  1.06. What is the ratio of the Value added (% of GDP) of Bulgaria in 1986 to that in 1990?
Make the answer very short. 1.32. What is the ratio of the Value added (% of GDP) of Ghana in 1986 to that in 1990?
Provide a short and direct response. 1.02. What is the ratio of the Value added (% of GDP) of Sub-Saharan Africa (developing only) in 1986 to that in 1991?
Your response must be concise. 1.01. What is the ratio of the Value added (% of GDP) of Upper middle income in 1986 to that in 1991?
Make the answer very short. 1.07. What is the ratio of the Value added (% of GDP) of Bulgaria in 1986 to that in 1991?
Keep it short and to the point. 1.49. What is the ratio of the Value added (% of GDP) of Ghana in 1986 to that in 1991?
Your answer should be compact. 1.02. What is the ratio of the Value added (% of GDP) of Sub-Saharan Africa (developing only) in 1987 to that in 1988?
Your answer should be compact. 1.02. What is the ratio of the Value added (% of GDP) of Upper middle income in 1987 to that in 1988?
Offer a terse response. 1.02. What is the ratio of the Value added (% of GDP) in Bulgaria in 1987 to that in 1988?
Offer a very short reply. 1.02. What is the ratio of the Value added (% of GDP) of Sub-Saharan Africa (developing only) in 1987 to that in 1989?
Your answer should be compact. 0.98. What is the ratio of the Value added (% of GDP) of Upper middle income in 1987 to that in 1989?
Provide a succinct answer. 1.05. What is the ratio of the Value added (% of GDP) in Bulgaria in 1987 to that in 1989?
Your answer should be very brief. 1.03. What is the ratio of the Value added (% of GDP) in Ghana in 1987 to that in 1989?
Provide a short and direct response. 0.97. What is the ratio of the Value added (% of GDP) in Upper middle income in 1987 to that in 1990?
Give a very brief answer. 1.07. What is the ratio of the Value added (% of GDP) in Bulgaria in 1987 to that in 1990?
Your answer should be very brief. 1.21. What is the ratio of the Value added (% of GDP) in Ghana in 1987 to that in 1990?
Ensure brevity in your answer.  0.97. What is the ratio of the Value added (% of GDP) of Upper middle income in 1987 to that in 1991?
Your answer should be compact. 1.08. What is the ratio of the Value added (% of GDP) in Bulgaria in 1987 to that in 1991?
Make the answer very short. 1.36. What is the ratio of the Value added (% of GDP) of Ghana in 1987 to that in 1991?
Offer a terse response. 0.96. What is the ratio of the Value added (% of GDP) of Sub-Saharan Africa (developing only) in 1988 to that in 1989?
Offer a terse response. 0.97. What is the ratio of the Value added (% of GDP) of Bulgaria in 1988 to that in 1989?
Offer a terse response. 1.01. What is the ratio of the Value added (% of GDP) of Ghana in 1988 to that in 1989?
Offer a very short reply. 0.98. What is the ratio of the Value added (% of GDP) of Sub-Saharan Africa (developing only) in 1988 to that in 1990?
Your answer should be very brief. 0.98. What is the ratio of the Value added (% of GDP) in Upper middle income in 1988 to that in 1990?
Your answer should be very brief. 1.05. What is the ratio of the Value added (% of GDP) in Bulgaria in 1988 to that in 1990?
Give a very brief answer. 1.18. What is the ratio of the Value added (% of GDP) in Ghana in 1988 to that in 1990?
Your answer should be compact. 0.98. What is the ratio of the Value added (% of GDP) of Sub-Saharan Africa (developing only) in 1988 to that in 1991?
Keep it short and to the point. 1. What is the ratio of the Value added (% of GDP) of Upper middle income in 1988 to that in 1991?
Give a very brief answer. 1.06. What is the ratio of the Value added (% of GDP) of Bulgaria in 1988 to that in 1991?
Ensure brevity in your answer.  1.33. What is the ratio of the Value added (% of GDP) in Ghana in 1988 to that in 1991?
Provide a succinct answer. 0.98. What is the ratio of the Value added (% of GDP) of Upper middle income in 1989 to that in 1990?
Keep it short and to the point. 1.03. What is the ratio of the Value added (% of GDP) of Bulgaria in 1989 to that in 1990?
Give a very brief answer. 1.17. What is the ratio of the Value added (% of GDP) of Ghana in 1989 to that in 1990?
Offer a very short reply. 1. What is the ratio of the Value added (% of GDP) of Sub-Saharan Africa (developing only) in 1989 to that in 1991?
Make the answer very short. 1.04. What is the ratio of the Value added (% of GDP) of Upper middle income in 1989 to that in 1991?
Your answer should be very brief. 1.03. What is the ratio of the Value added (% of GDP) of Bulgaria in 1989 to that in 1991?
Keep it short and to the point. 1.32. What is the ratio of the Value added (% of GDP) in Sub-Saharan Africa (developing only) in 1990 to that in 1991?
Give a very brief answer. 1.03. What is the ratio of the Value added (% of GDP) in Upper middle income in 1990 to that in 1991?
Your answer should be compact. 1.01. What is the ratio of the Value added (% of GDP) of Bulgaria in 1990 to that in 1991?
Your response must be concise. 1.12. What is the ratio of the Value added (% of GDP) in Ghana in 1990 to that in 1991?
Ensure brevity in your answer.  0.99. What is the difference between the highest and the second highest Value added (% of GDP) of Sub-Saharan Africa (developing only)?
Make the answer very short. 0.48. What is the difference between the highest and the second highest Value added (% of GDP) of Upper middle income?
Provide a short and direct response. 0.31. What is the difference between the highest and the second highest Value added (% of GDP) of Bulgaria?
Your answer should be compact. 5.63. What is the difference between the highest and the second highest Value added (% of GDP) in Ghana?
Your answer should be very brief. 0.26. What is the difference between the highest and the lowest Value added (% of GDP) in Sub-Saharan Africa (developing only)?
Provide a short and direct response. 1.34. What is the difference between the highest and the lowest Value added (% of GDP) of Upper middle income?
Ensure brevity in your answer.  3.05. What is the difference between the highest and the lowest Value added (% of GDP) of Bulgaria?
Your response must be concise. 21.36. What is the difference between the highest and the lowest Value added (% of GDP) of Ghana?
Keep it short and to the point. 0.89. 